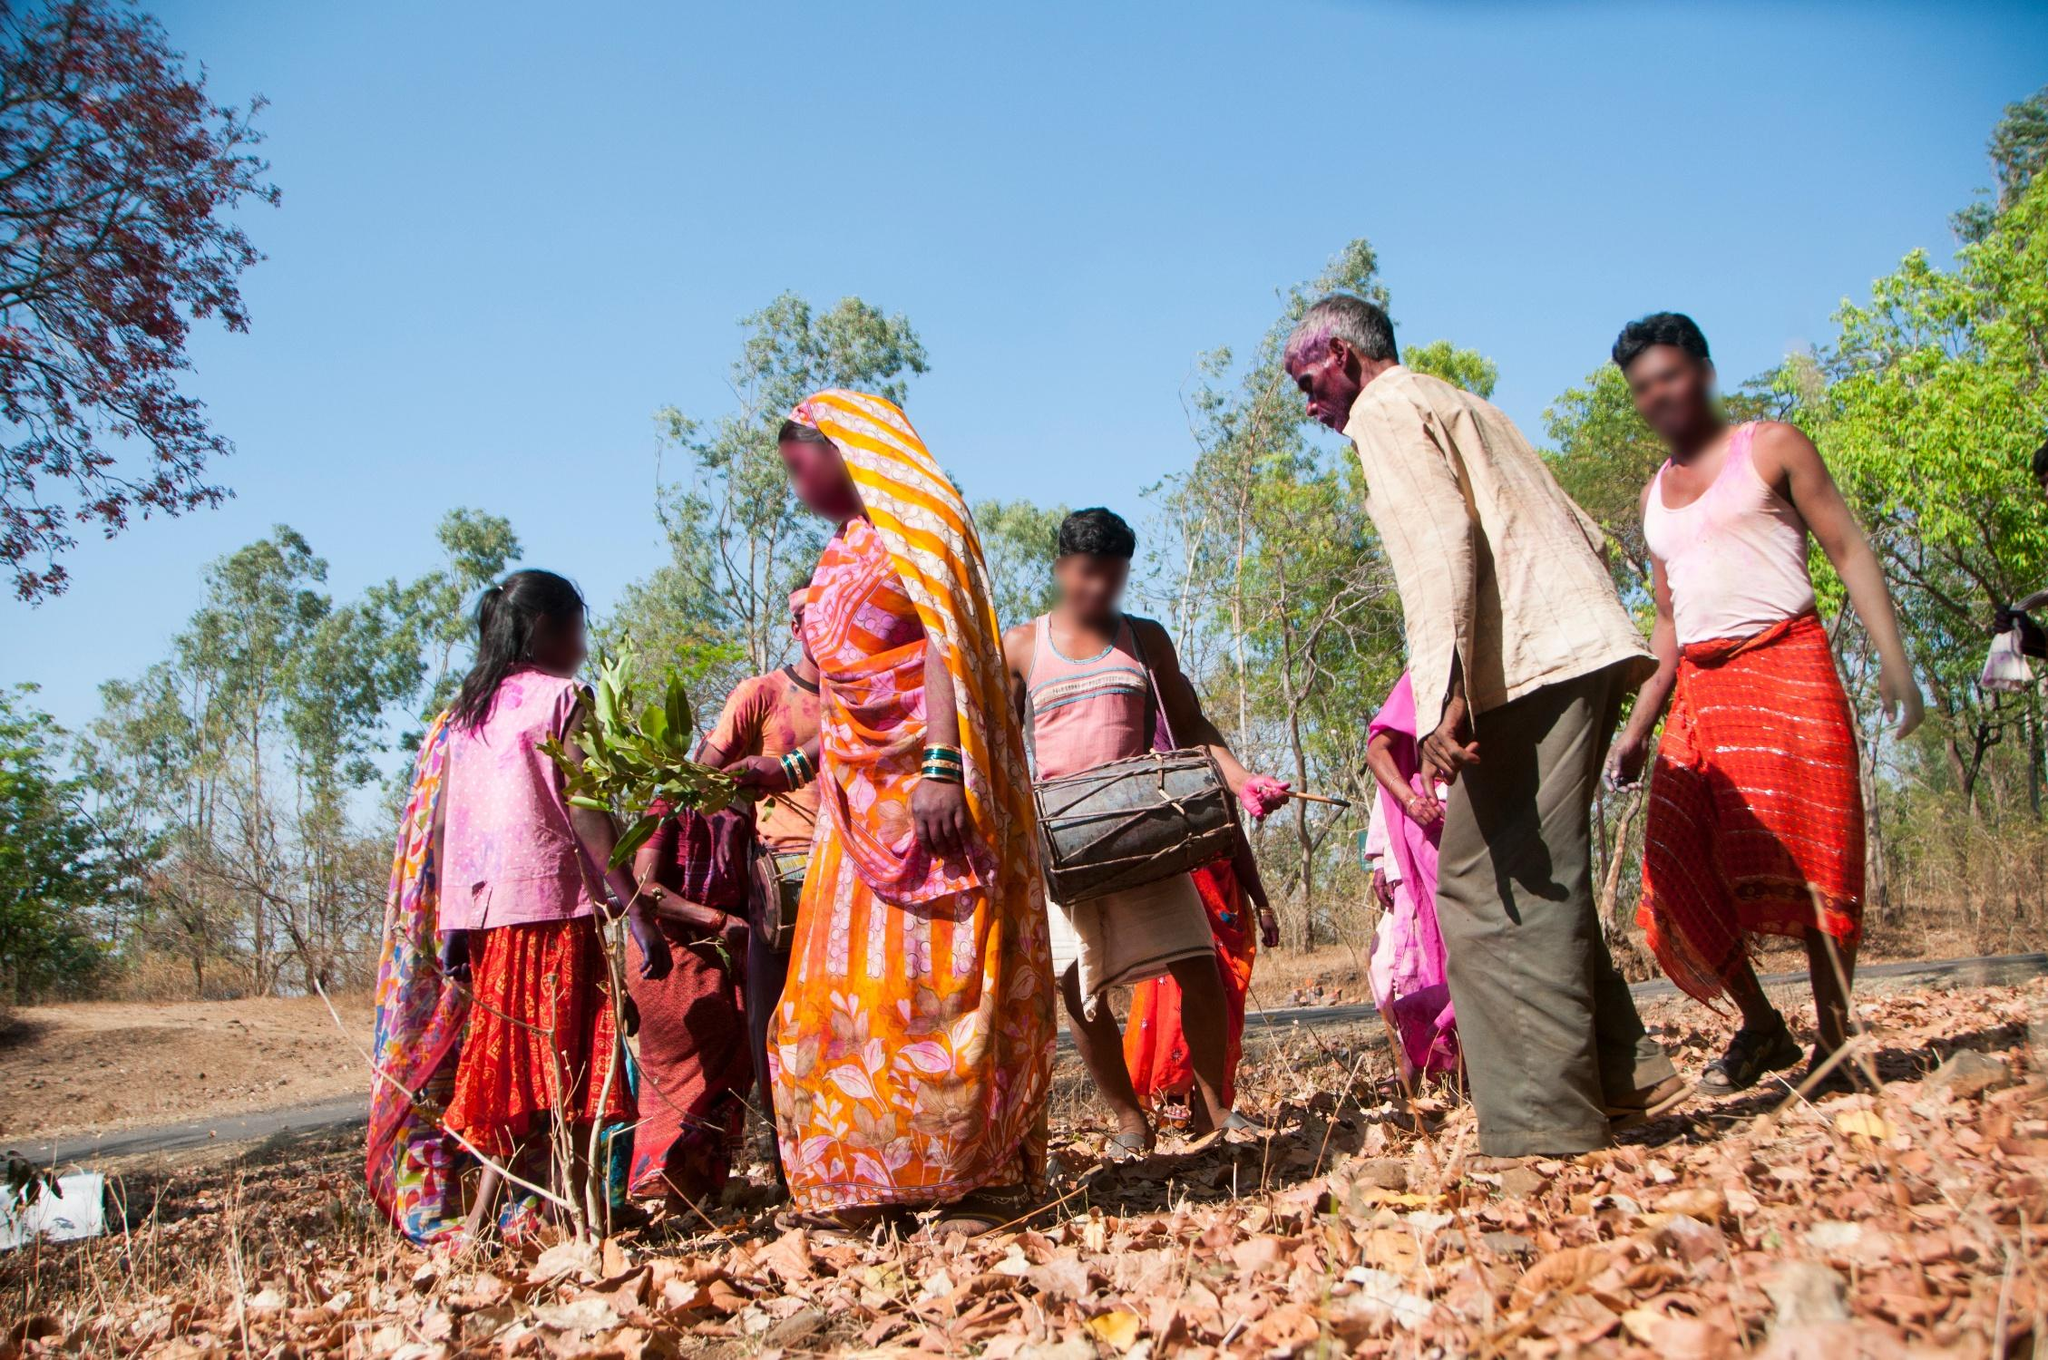Describe a scenario where this image is part of a historical archive; what significance might it have? As part of a historical archive, this image captures a significant moment of community life in a rural area. It would be a valuable resource illustrating traditional agricultural practices and communal labor. The bright clothing and tools provide insight into the material culture of the time, and the environment shows the close relationship between the people and their natural surroundings.  If you had to create a title for this photograph, what would it be? A fitting title for this photograph would be 'Harmony in Harvest: A Tapestry of Tradition and Togetherness.' This title encapsulates the essence of communal effort, vibrant cultural practices, and the connection between people and nature. 